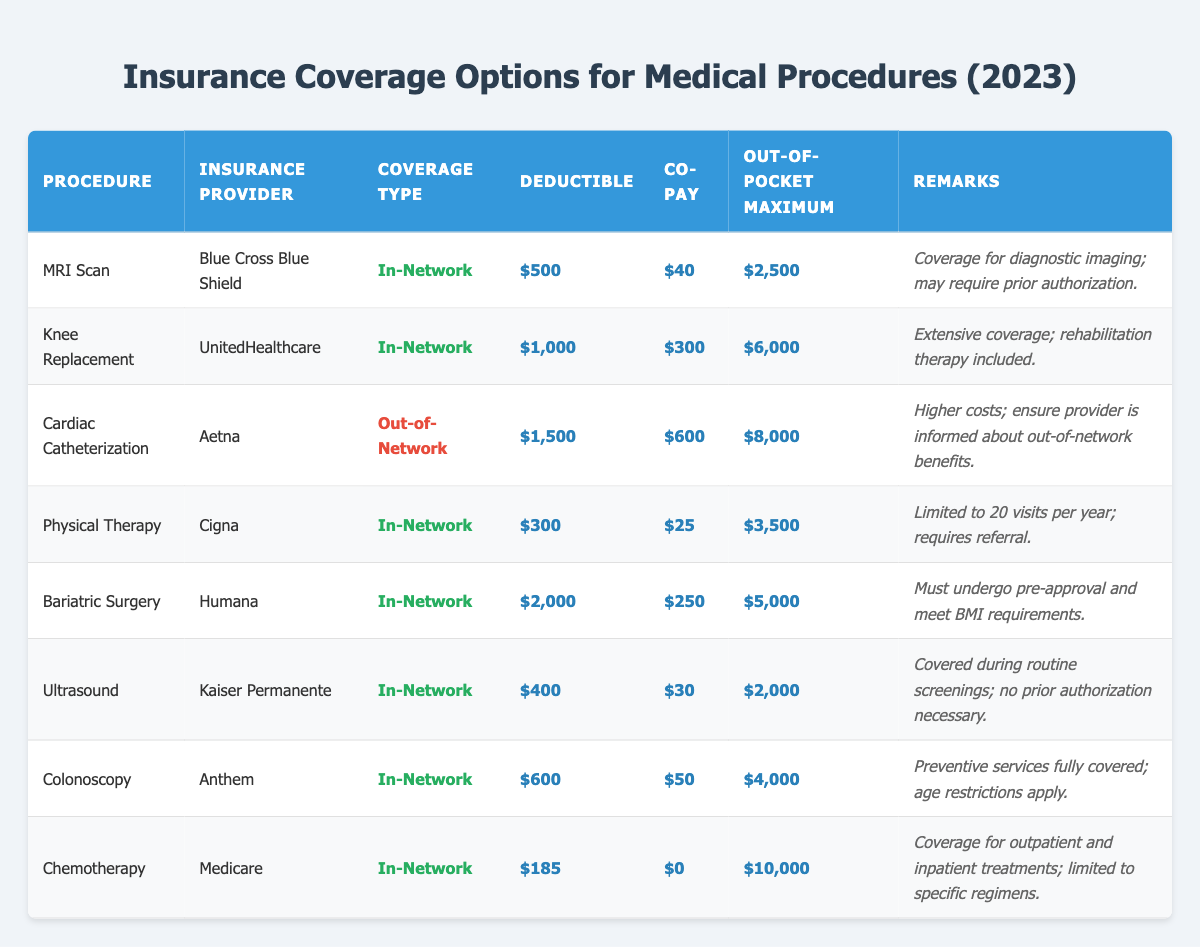What is the deductible for an MRI Scan under Blue Cross Blue Shield? The table shows the deductible for an MRI Scan is listed under the "Deductible" column for Blue Cross Blue Shield. The value given is $500.
Answer: $500 What is the co-pay amount for chemotherapy under Medicare? The "Co-Pay" column indicates that the co-pay amount for chemotherapy under Medicare is $0.
Answer: $0 Which insurance provider has the highest out-of-pocket maximum for knee replacement? The table lists the out-of-pocket maximum for knee replacement as $6,000 under UnitedHealthcare, which is the highest amount for that procedure.
Answer: UnitedHealthcare What procedure has the lowest deductible? By examining the deductible values, the lowest deductible is $185 for chemotherapy under Medicare.
Answer: Chemotherapy Is physical therapy capped at a certain number of visits per year? Yes, the remarks for physical therapy indicate it is limited to 20 visits per year.
Answer: Yes What is the difference in out-of-pocket maximum between cardiac catheterization and bariatric surgery? The out-of-pocket maximum for cardiac catheterization is $8,000 and for bariatric surgery is $5,000. The difference is calculated as $8,000 - $5,000 = $3,000.
Answer: $3,000 How many procedures are covered in-network by Cigna? The table lists physical therapy as the only procedure covered in-network by Cigna.
Answer: 1 Which procedure requires pre-approval and has specific BMI requirements? The remarks for bariatric surgery indicate that it requires pre-approval and adherence to BMI requirements.
Answer: Bariatric Surgery What is the total co-pay for out-of-network cardiac catheterization? The co-pay amount for out-of-network cardiac catheterization is $600, as noted in the corresponding row of the table.
Answer: $600 If someone has a deductible of $1,000, which procedures would not meet this requirement? The only procedures with deductibles lower than $1,000 are MRI Scan ($500), physical therapy ($300), and chemotherapy ($185). Therefore, knee replacement, cardiac catheterization, bariatric surgery, ultrasound, and colonoscopy exceed the deductible amount.
Answer: MRI Scan, Physical Therapy, Chemotherapy 